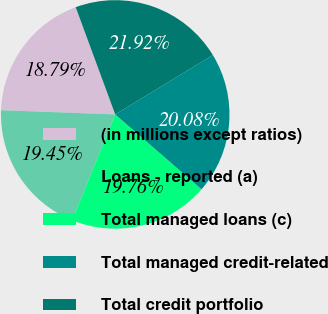Convert chart. <chart><loc_0><loc_0><loc_500><loc_500><pie_chart><fcel>(in millions except ratios)<fcel>Loans - reported (a)<fcel>Total managed loans (c)<fcel>Total managed credit-related<fcel>Total credit portfolio<nl><fcel>18.79%<fcel>19.45%<fcel>19.76%<fcel>20.08%<fcel>21.92%<nl></chart> 